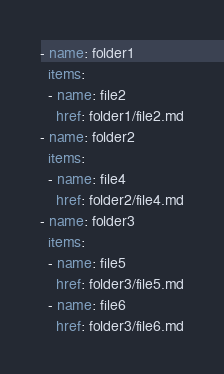<code> <loc_0><loc_0><loc_500><loc_500><_YAML_>- name: folder1
  items:
  - name: file2
    href: folder1/file2.md
- name: folder2
  items:
  - name: file4
    href: folder2/file4.md
- name: folder3
  items:
  - name: file5
    href: folder3/file5.md
  - name: file6
    href: folder3/file6.md
</code> 